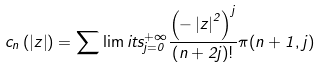Convert formula to latex. <formula><loc_0><loc_0><loc_500><loc_500>c _ { n } \left ( \left | z \right | \right ) = \sum \lim i t s _ { j = 0 } ^ { + \infty } \frac { \left ( - \left | z \right | ^ { 2 } \right ) ^ { j } } { \left ( n + 2 j \right ) ! } \pi ( n + 1 , j )</formula> 